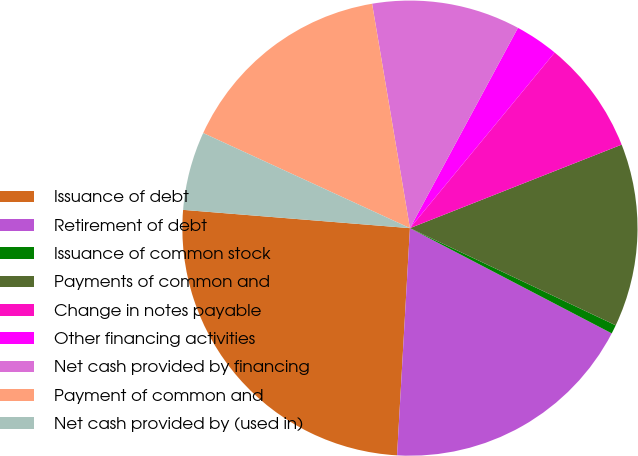<chart> <loc_0><loc_0><loc_500><loc_500><pie_chart><fcel>Issuance of debt<fcel>Retirement of debt<fcel>Issuance of common stock<fcel>Payments of common and<fcel>Change in notes payable<fcel>Other financing activities<fcel>Net cash provided by financing<fcel>Payment of common and<fcel>Net cash provided by (used in)<nl><fcel>25.38%<fcel>18.25%<fcel>0.63%<fcel>13.0%<fcel>8.05%<fcel>3.1%<fcel>10.53%<fcel>15.48%<fcel>5.58%<nl></chart> 